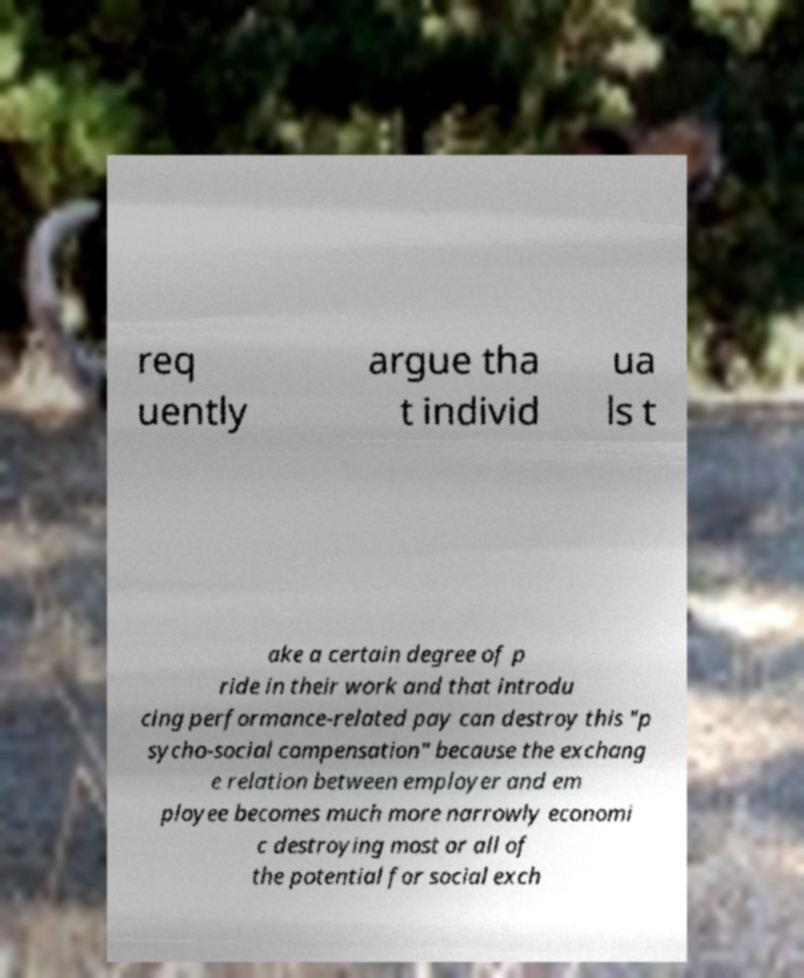For documentation purposes, I need the text within this image transcribed. Could you provide that? req uently argue tha t individ ua ls t ake a certain degree of p ride in their work and that introdu cing performance-related pay can destroy this "p sycho-social compensation" because the exchang e relation between employer and em ployee becomes much more narrowly economi c destroying most or all of the potential for social exch 